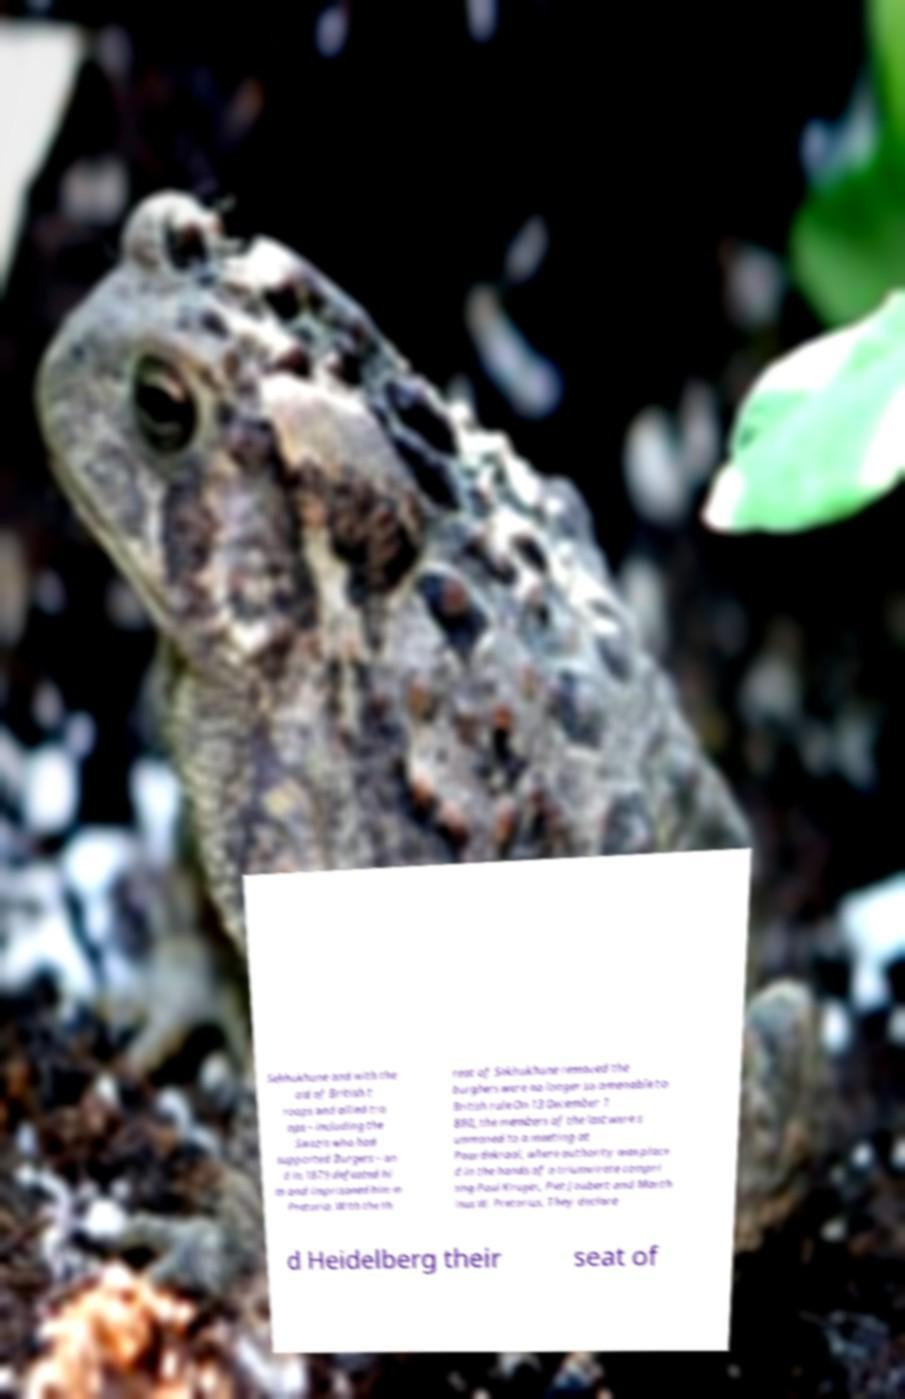What messages or text are displayed in this image? I need them in a readable, typed format. Sekhukhune and with the aid of British t roops and allied tro ops – including the Swazis who had supported Burgers – an d in 1879 defeated hi m and imprisoned him in Pretoria. With the th reat of Sekhukhune removed the burghers were no longer so amenable to British rule.On 13 December 1 880, the members of the last were s ummoned to a meeting at Paardekraal, where authority was place d in the hands of a triumvirate compri sing Paul Kruger, Piet Joubert and Marth inus W. Pretorius. They declare d Heidelberg their seat of 